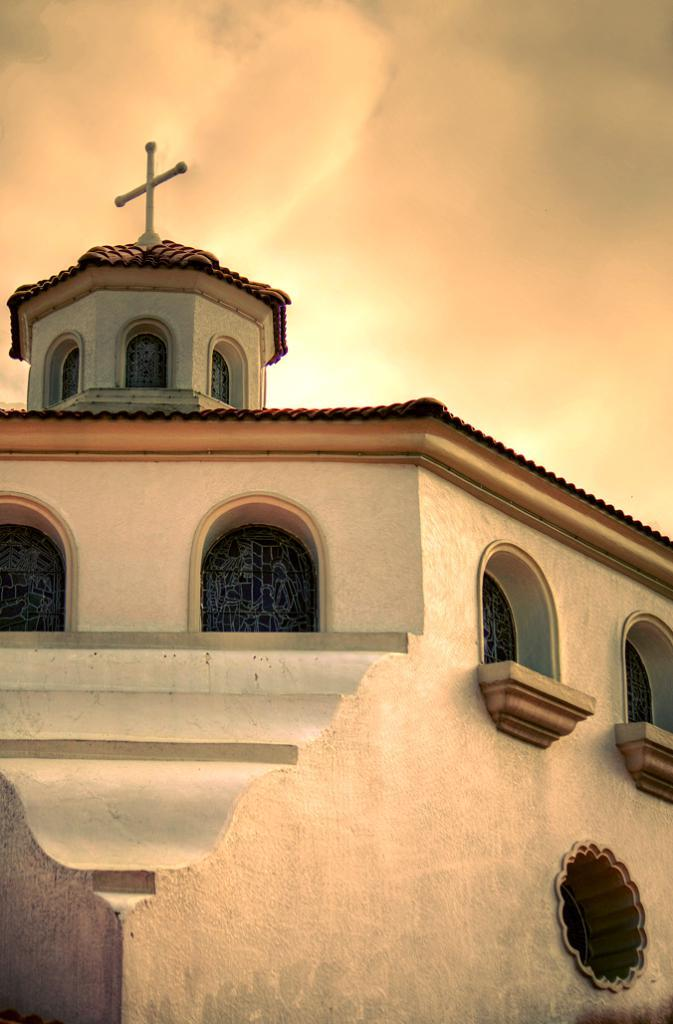What can be seen in the center of the image? The sky is visible in the center of the image. What architectural features are present in the image? There are windows and a wall in the image. How many buildings can be seen in the image? There is one building in the image. What religious symbol is present in the image? There is a cross in the image. How many beds are visible in the image? There are no beds present in the image. What type of pet can be seen interacting with the cross in the image? There are no pets present in the image, and the cross is not being interacted with. 